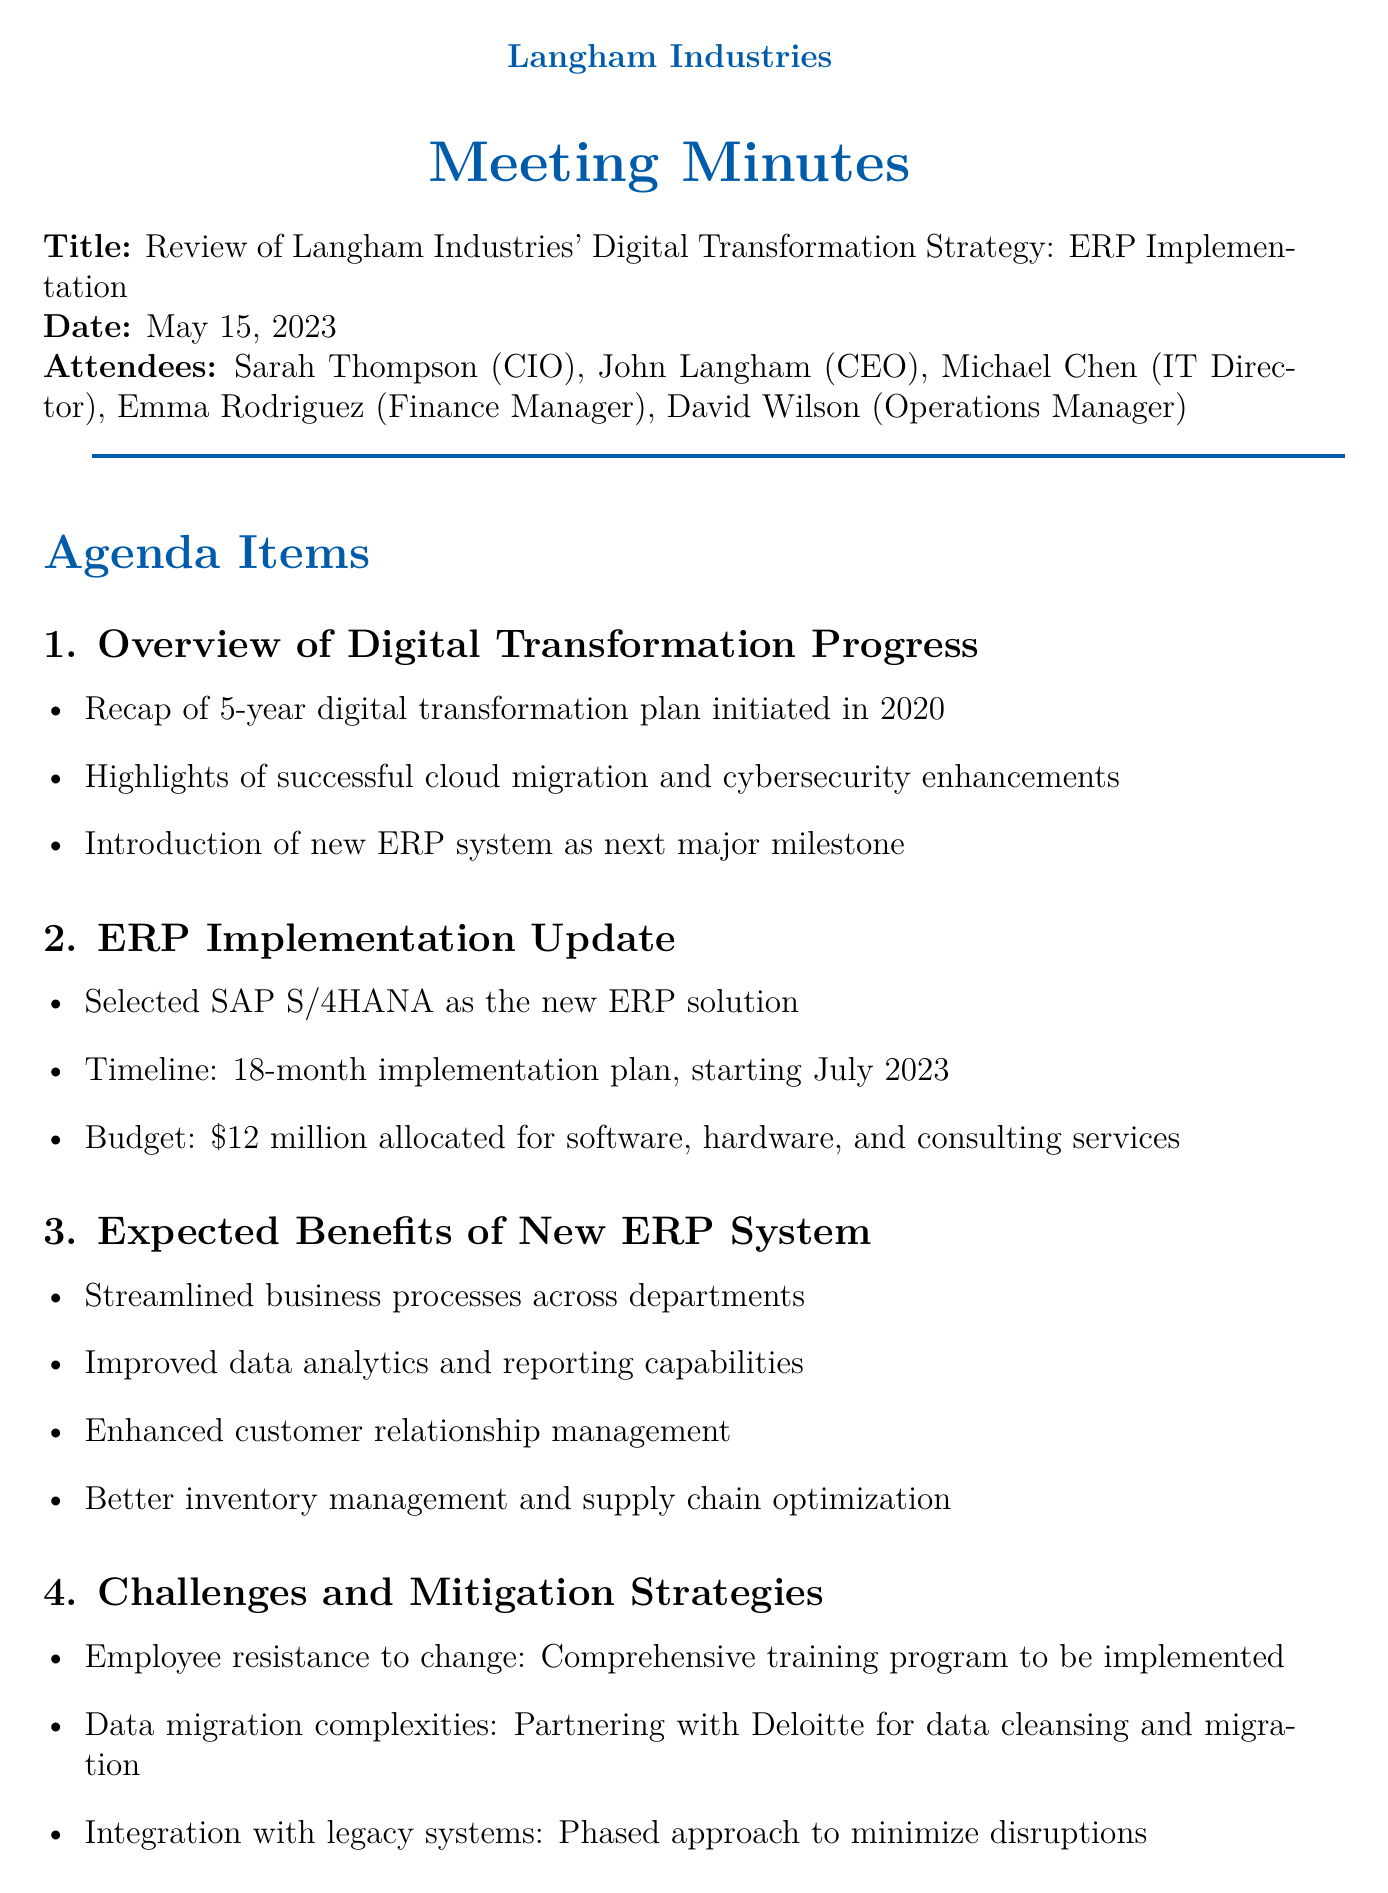What is the title of the meeting? The title is the main subject of the document, which is provided in the header section.
Answer: Review of Langham Industries' Digital Transformation Strategy: ERP Implementation Who is the CEO of Langham Industries? The document lists the attendees, providing the roles and names of the participants.
Answer: John Langham When is the ERP implementation planned to start? The timeline for the ERP implementation project is outlined in the project update section.
Answer: July 2023 What is the budget allocated for the new ERP system? The budget information is mentioned under the ERP Implementation Update agenda item.
Answer: $12 million What major challenges are identified in the document? The document mentions key challenges that the company anticipates during the ERP implementation process.
Answer: Employee resistance to change, Data migration complexities, Integration with legacy systems Who is responsible for preparing the ERP implementation kickoff presentation? The action items list includes tasks along with the assigned individuals for each task.
Answer: Michael Chen What is the due date for developing the employee communication plan? The due date for the specific task is provided in the action items section.
Answer: June 15, 2023 What is one expected benefit of the new ERP system? The document lists various benefits expected from implementing the new ERP system.
Answer: Streamlined business processes across departments How often will progress updates be scheduled for the executive team? The document states the frequency of updates as part of the next steps for the project.
Answer: Monthly 